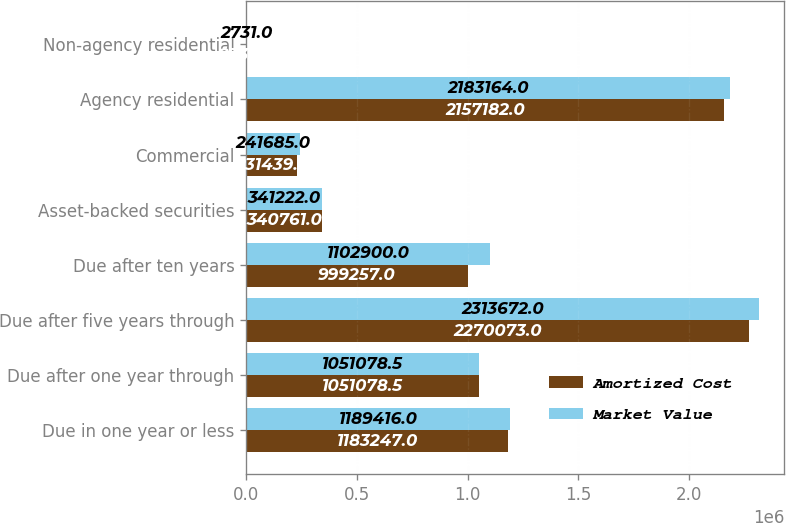Convert chart to OTSL. <chart><loc_0><loc_0><loc_500><loc_500><stacked_bar_chart><ecel><fcel>Due in one year or less<fcel>Due after one year through<fcel>Due after five years through<fcel>Due after ten years<fcel>Asset-backed securities<fcel>Commercial<fcel>Agency residential<fcel>Non-agency residential<nl><fcel>Amortized Cost<fcel>1.18325e+06<fcel>1.05108e+06<fcel>2.27007e+06<fcel>999257<fcel>340761<fcel>231439<fcel>2.15718e+06<fcel>2734<nl><fcel>Market Value<fcel>1.18942e+06<fcel>1.05108e+06<fcel>2.31367e+06<fcel>1.1029e+06<fcel>341222<fcel>241685<fcel>2.18316e+06<fcel>2731<nl></chart> 